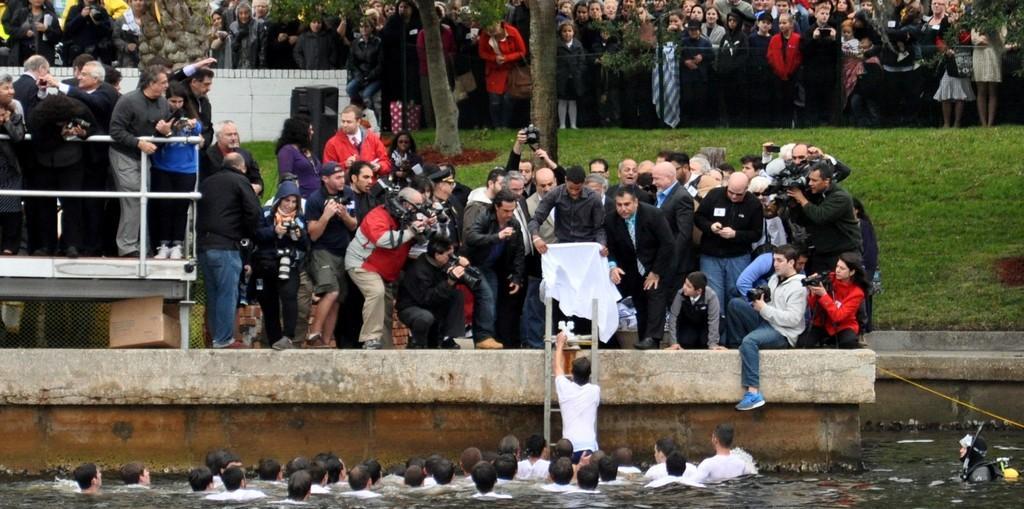Can you describe this image briefly? In this picture I can see few people standing and few of them holding cameras in their hands and I can see a group of people in the water and a man climbing the ladder and I can see a man holding cloth in his hands and I can see trees and grass on the ground. 